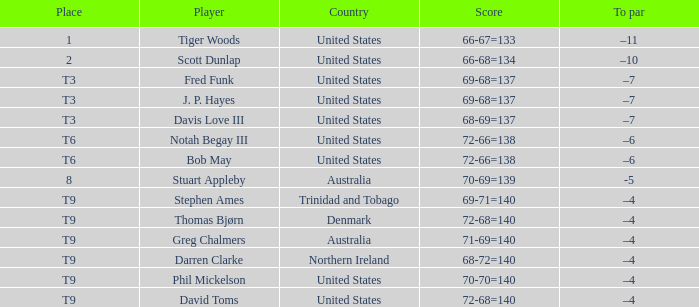What country is Darren Clarke from? Northern Ireland. 